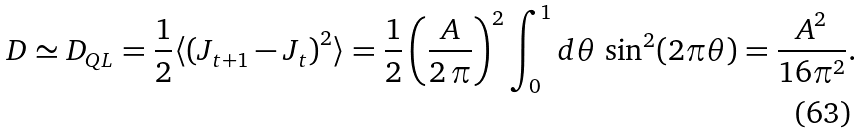<formula> <loc_0><loc_0><loc_500><loc_500>D \simeq D _ { Q L } = \frac { 1 } { 2 } \langle \left ( J _ { t + 1 } - J _ { t } \right ) ^ { 2 } \rangle = \frac { 1 } { 2 } \left ( \frac { A } { 2 \, \pi } \right ) ^ { 2 } \int _ { 0 } ^ { 1 } d \theta \, \sin ^ { 2 } ( 2 \pi \theta ) = \frac { A ^ { 2 } } { 1 6 \pi ^ { 2 } } .</formula> 